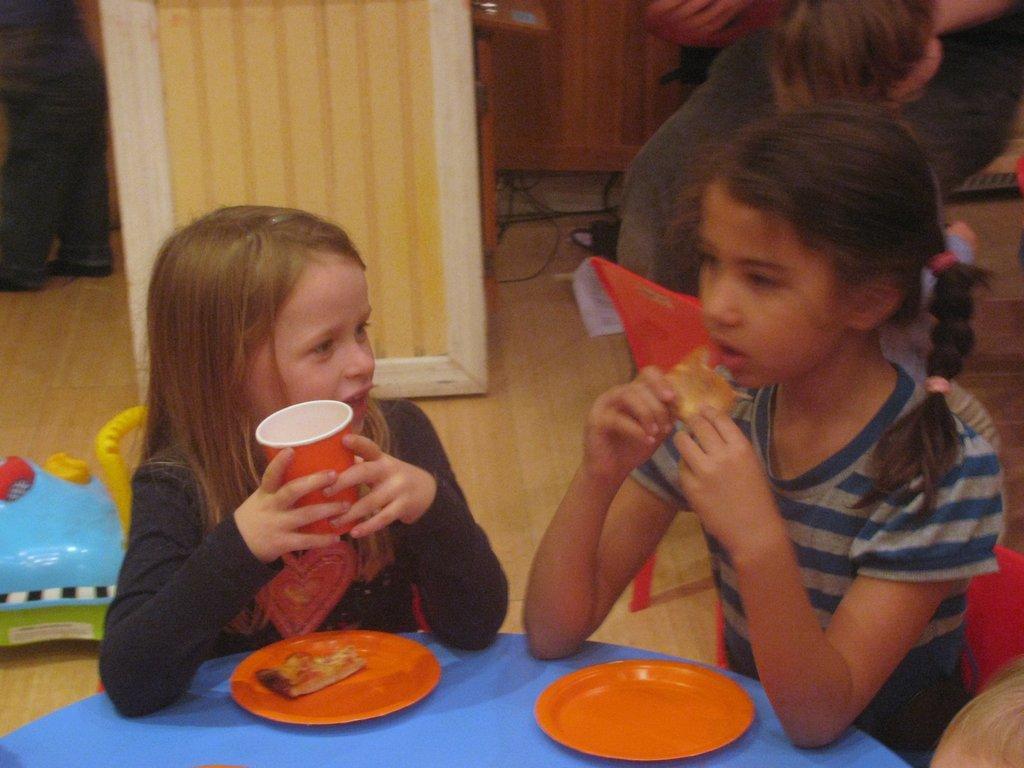Could you give a brief overview of what you see in this image? In this image we can see two children sitting. One girl is holding a glass and another girl is holding a food item. In front of them there are plates on a blue surface. On the plate there is a food item. In the back there is a toy. Also there is a chair. And there are few people in the background. 